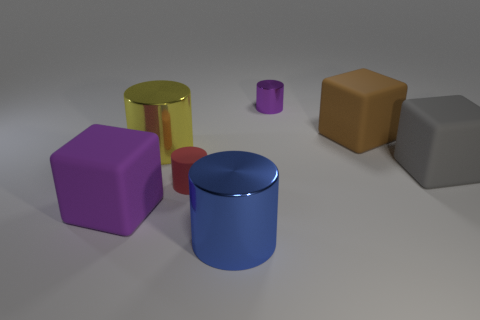Subtract all red matte cylinders. How many cylinders are left? 3 Subtract 1 cylinders. How many cylinders are left? 3 Subtract all red cylinders. How many cylinders are left? 3 Add 2 gray blocks. How many objects exist? 9 Subtract all green cylinders. Subtract all gray spheres. How many cylinders are left? 4 Subtract all cubes. How many objects are left? 4 Add 4 tiny red cylinders. How many tiny red cylinders exist? 5 Subtract 0 purple balls. How many objects are left? 7 Subtract all tiny yellow metallic things. Subtract all big yellow shiny cylinders. How many objects are left? 6 Add 6 tiny red matte things. How many tiny red matte things are left? 7 